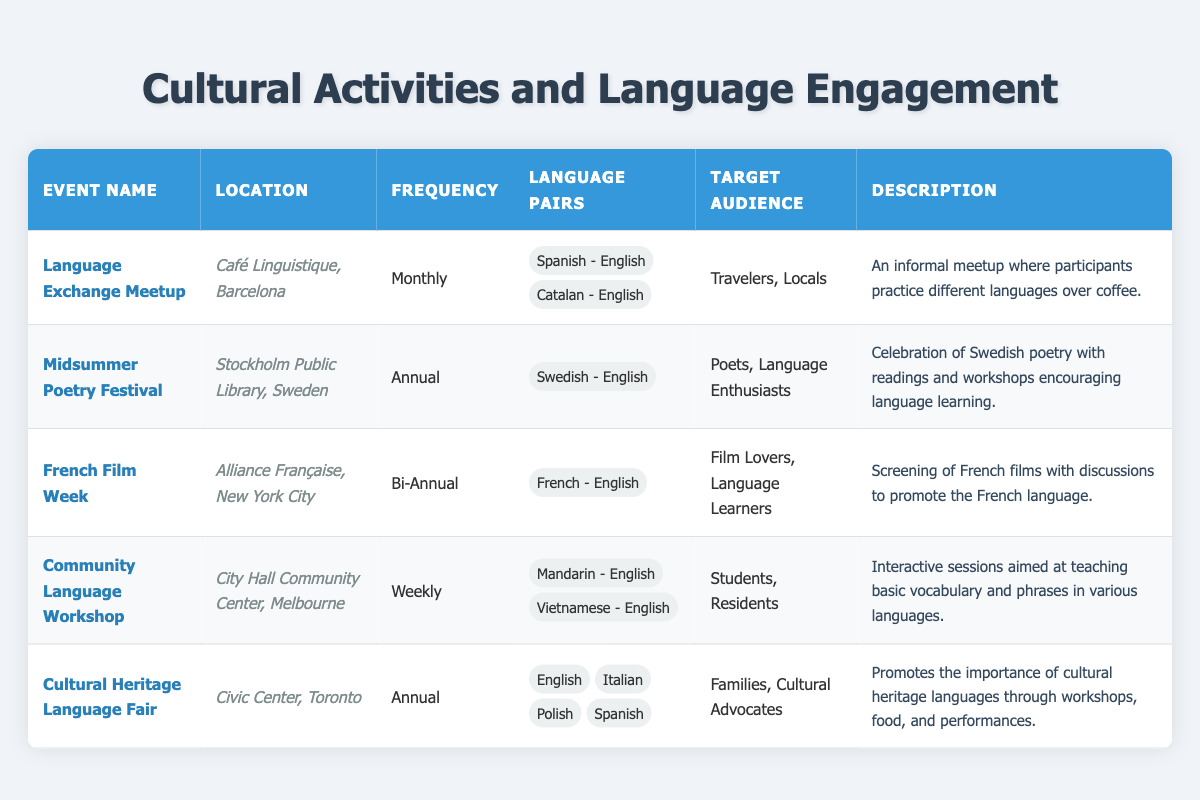What is the frequency of the Language Exchange Meetup? The frequency of an event can be found directly in the table under the "Frequency" column for the "Language Exchange Meetup" row. It states "Monthly".
Answer: Monthly Which event occurs more often, the Community Language Workshop or the Midsummer Poetry Festival? The frequency of the Community Language Workshop is "Weekly" and the Midsummer Poetry Festival is "Annual". Since there are about 52 weeks in a year, the Community Language Workshop occurs more frequently than the Midsummer Poetry Festival.
Answer: Community Language Workshop Is the Cultural Heritage Language Fair held in Toronto? By checking the "Location" column for Cultural Heritage Language Fair in the table, it is confirmed that the event is held in "Civic Center, Toronto".
Answer: Yes How many languages are paired with Mandarin in the Community Language Workshop? The Community Language Workshop lists two language pairs: "Mandarin - English" and "Vietnamese - English". Thus, there is 1 language paired with Mandarin: English.
Answer: 1 What is the total number of language pairs across all events in the table? To find the total number of language pairs, the distinct pairs from each event must be counted: 2 (Language Exchange Meetup) + 1 (Midsummer Poetry Festival) + 1 (French Film Week) + 2 (Community Language Workshop) + 4 (Cultural Heritage Language Fair) totals to 10.
Answer: 10 Are all events targeted toward families or cultural advocates? From the "Target Audience" column, only the Cultural Heritage Language Fair explicitly mentions "Families, Cultural Advocates"; other events target different audiences. Therefore, the statement is false.
Answer: No Which event has the least frequency and what is its location? The event needed with the least frequency is the Midsummer Poetry Festival, which occurs "Annual", and it is held at "Stockholm Public Library, Sweden".
Answer: Midsummer Poetry Festival, Stockholm Public Library, Sweden What can be inferred about the target audience of the French Film Week? The French Film Week targets "Film Lovers, Language Learners", indicating that it appeals to individuals interested in films and those aiming to improve their French language skills. This suggests that the audience may have a cultural interest in both film and language learning.
Answer: Film Lovers, Language Learners 